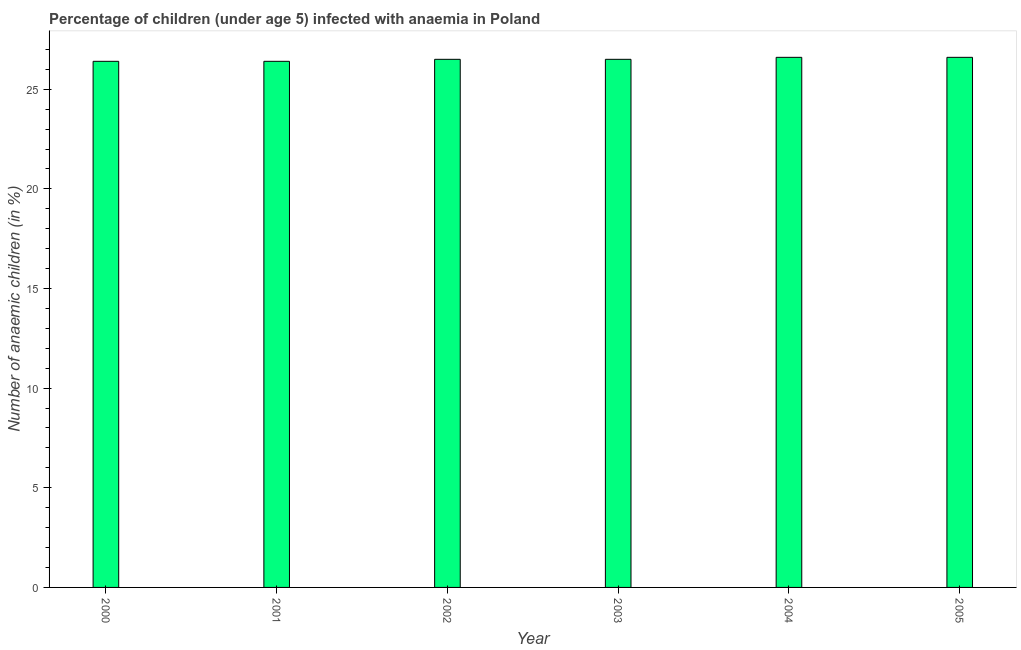Does the graph contain any zero values?
Your response must be concise. No. Does the graph contain grids?
Offer a terse response. No. What is the title of the graph?
Offer a very short reply. Percentage of children (under age 5) infected with anaemia in Poland. What is the label or title of the X-axis?
Offer a terse response. Year. What is the label or title of the Y-axis?
Provide a short and direct response. Number of anaemic children (in %). What is the number of anaemic children in 2005?
Give a very brief answer. 26.6. Across all years, what is the maximum number of anaemic children?
Your response must be concise. 26.6. Across all years, what is the minimum number of anaemic children?
Your response must be concise. 26.4. In which year was the number of anaemic children maximum?
Keep it short and to the point. 2004. What is the sum of the number of anaemic children?
Your answer should be compact. 159. What is the average number of anaemic children per year?
Your answer should be compact. 26.5. In how many years, is the number of anaemic children greater than 25 %?
Give a very brief answer. 6. Do a majority of the years between 2003 and 2001 (inclusive) have number of anaemic children greater than 3 %?
Offer a very short reply. Yes. Is the number of anaemic children in 2001 less than that in 2003?
Make the answer very short. Yes. Is the difference between the number of anaemic children in 2002 and 2003 greater than the difference between any two years?
Offer a very short reply. No. In how many years, is the number of anaemic children greater than the average number of anaemic children taken over all years?
Keep it short and to the point. 2. Are all the bars in the graph horizontal?
Your response must be concise. No. Are the values on the major ticks of Y-axis written in scientific E-notation?
Your answer should be compact. No. What is the Number of anaemic children (in %) in 2000?
Provide a short and direct response. 26.4. What is the Number of anaemic children (in %) in 2001?
Give a very brief answer. 26.4. What is the Number of anaemic children (in %) of 2004?
Your answer should be very brief. 26.6. What is the Number of anaemic children (in %) of 2005?
Offer a very short reply. 26.6. What is the difference between the Number of anaemic children (in %) in 2000 and 2005?
Make the answer very short. -0.2. What is the difference between the Number of anaemic children (in %) in 2001 and 2002?
Ensure brevity in your answer.  -0.1. What is the difference between the Number of anaemic children (in %) in 2001 and 2004?
Make the answer very short. -0.2. What is the difference between the Number of anaemic children (in %) in 2002 and 2003?
Ensure brevity in your answer.  0. What is the difference between the Number of anaemic children (in %) in 2002 and 2004?
Make the answer very short. -0.1. What is the difference between the Number of anaemic children (in %) in 2002 and 2005?
Provide a short and direct response. -0.1. What is the difference between the Number of anaemic children (in %) in 2003 and 2004?
Give a very brief answer. -0.1. What is the difference between the Number of anaemic children (in %) in 2003 and 2005?
Keep it short and to the point. -0.1. What is the difference between the Number of anaemic children (in %) in 2004 and 2005?
Your response must be concise. 0. What is the ratio of the Number of anaemic children (in %) in 2000 to that in 2004?
Your answer should be very brief. 0.99. What is the ratio of the Number of anaemic children (in %) in 2001 to that in 2003?
Your answer should be very brief. 1. What is the ratio of the Number of anaemic children (in %) in 2002 to that in 2003?
Keep it short and to the point. 1. What is the ratio of the Number of anaemic children (in %) in 2003 to that in 2004?
Your response must be concise. 1. 